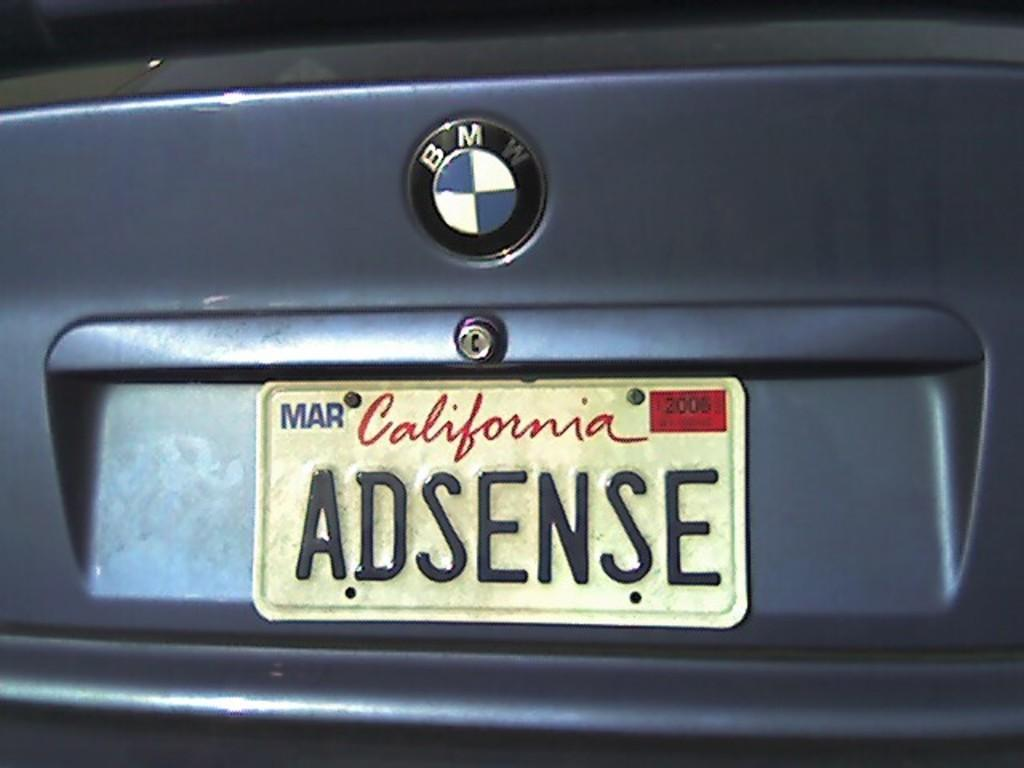<image>
Render a clear and concise summary of the photo. A blue BMW has a dirt license plate that says ADSENSE. 